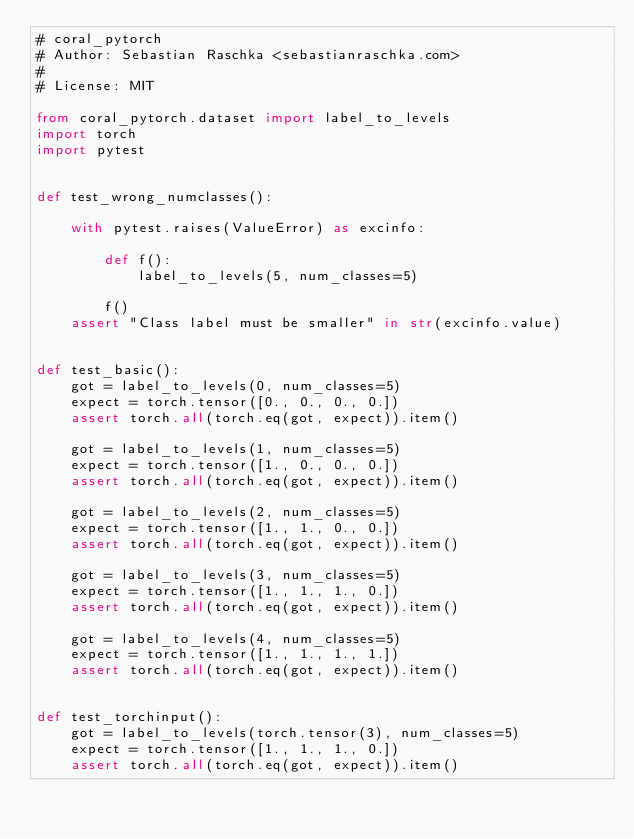Convert code to text. <code><loc_0><loc_0><loc_500><loc_500><_Python_># coral_pytorch
# Author: Sebastian Raschka <sebastianraschka.com>
#
# License: MIT

from coral_pytorch.dataset import label_to_levels
import torch
import pytest


def test_wrong_numclasses():

    with pytest.raises(ValueError) as excinfo:

        def f():
            label_to_levels(5, num_classes=5)

        f()
    assert "Class label must be smaller" in str(excinfo.value)


def test_basic():
    got = label_to_levels(0, num_classes=5)
    expect = torch.tensor([0., 0., 0., 0.])
    assert torch.all(torch.eq(got, expect)).item()

    got = label_to_levels(1, num_classes=5)
    expect = torch.tensor([1., 0., 0., 0.])
    assert torch.all(torch.eq(got, expect)).item()

    got = label_to_levels(2, num_classes=5)
    expect = torch.tensor([1., 1., 0., 0.])
    assert torch.all(torch.eq(got, expect)).item()

    got = label_to_levels(3, num_classes=5)
    expect = torch.tensor([1., 1., 1., 0.])
    assert torch.all(torch.eq(got, expect)).item()

    got = label_to_levels(4, num_classes=5)
    expect = torch.tensor([1., 1., 1., 1.])
    assert torch.all(torch.eq(got, expect)).item()


def test_torchinput():
    got = label_to_levels(torch.tensor(3), num_classes=5)
    expect = torch.tensor([1., 1., 1., 0.])
    assert torch.all(torch.eq(got, expect)).item()
</code> 